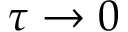Convert formula to latex. <formula><loc_0><loc_0><loc_500><loc_500>\tau \rightarrow 0</formula> 